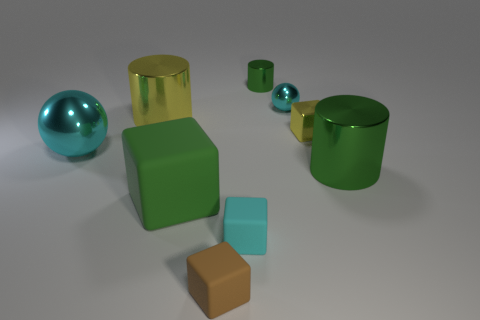Subtract all tiny metal cylinders. How many cylinders are left? 2 Subtract all blue spheres. How many green cylinders are left? 2 Subtract all yellow cylinders. How many cylinders are left? 2 Subtract 2 blocks. How many blocks are left? 2 Add 4 metallic spheres. How many metallic spheres are left? 6 Add 5 green cubes. How many green cubes exist? 6 Subtract 2 green cylinders. How many objects are left? 7 Subtract all cylinders. How many objects are left? 6 Subtract all blue balls. Subtract all purple cylinders. How many balls are left? 2 Subtract all green matte things. Subtract all large gray metal things. How many objects are left? 8 